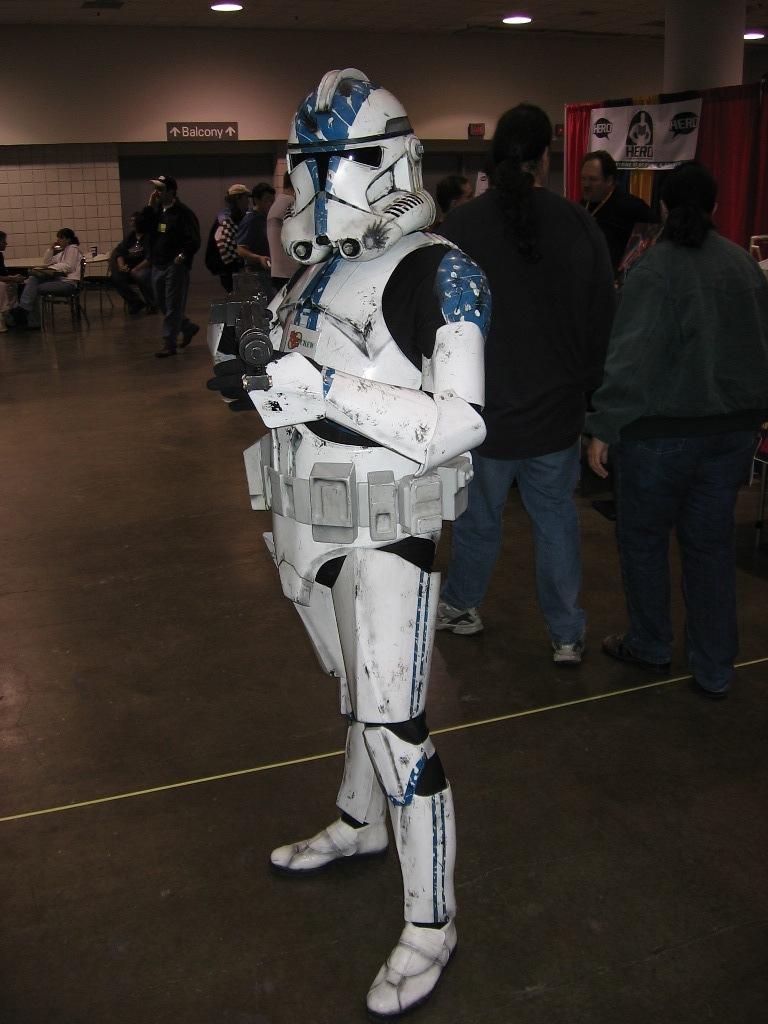Please provide a concise description of this image. In this image there is man, he is wearing a fashion dress,behind him there are persons walking. 